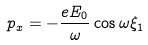<formula> <loc_0><loc_0><loc_500><loc_500>p _ { x } = - \frac { e E _ { 0 } } { \omega } \cos \omega \xi _ { 1 }</formula> 